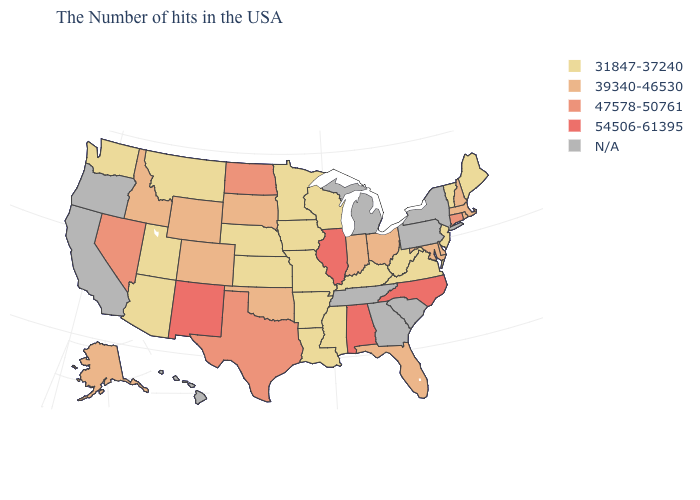Name the states that have a value in the range 31847-37240?
Write a very short answer. Maine, Vermont, New Jersey, Virginia, West Virginia, Kentucky, Wisconsin, Mississippi, Louisiana, Missouri, Arkansas, Minnesota, Iowa, Kansas, Nebraska, Utah, Montana, Arizona, Washington. Is the legend a continuous bar?
Write a very short answer. No. Which states have the lowest value in the USA?
Short answer required. Maine, Vermont, New Jersey, Virginia, West Virginia, Kentucky, Wisconsin, Mississippi, Louisiana, Missouri, Arkansas, Minnesota, Iowa, Kansas, Nebraska, Utah, Montana, Arizona, Washington. Name the states that have a value in the range 39340-46530?
Quick response, please. Massachusetts, Rhode Island, New Hampshire, Delaware, Maryland, Ohio, Florida, Indiana, Oklahoma, South Dakota, Wyoming, Colorado, Idaho, Alaska. Name the states that have a value in the range 47578-50761?
Be succinct. Connecticut, Texas, North Dakota, Nevada. Does the first symbol in the legend represent the smallest category?
Give a very brief answer. Yes. How many symbols are there in the legend?
Give a very brief answer. 5. Among the states that border Missouri , does Illinois have the highest value?
Quick response, please. Yes. Among the states that border Illinois , does Missouri have the highest value?
Be succinct. No. Does Alabama have the highest value in the USA?
Answer briefly. Yes. Name the states that have a value in the range N/A?
Quick response, please. New York, Pennsylvania, South Carolina, Georgia, Michigan, Tennessee, California, Oregon, Hawaii. What is the value of Utah?
Write a very short answer. 31847-37240. Does the map have missing data?
Short answer required. Yes. Among the states that border Indiana , does Ohio have the highest value?
Write a very short answer. No. Does the first symbol in the legend represent the smallest category?
Give a very brief answer. Yes. 